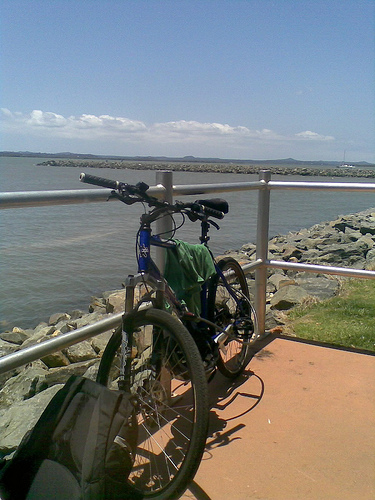<image>
Can you confirm if the sky is behind the mountain? Yes. From this viewpoint, the sky is positioned behind the mountain, with the mountain partially or fully occluding the sky. 